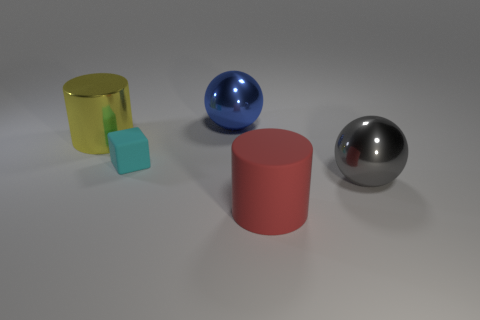What is the color of the object that is both on the left side of the big gray metal ball and to the right of the big blue sphere?
Offer a very short reply. Red. What number of cyan things are the same size as the red rubber object?
Provide a short and direct response. 0. How big is the thing that is left of the blue metallic sphere and in front of the big yellow shiny cylinder?
Provide a short and direct response. Small. How many large blue things are in front of the big shiny ball on the left side of the ball that is to the right of the blue shiny object?
Provide a succinct answer. 0. Are there any large matte things that have the same color as the large metallic cylinder?
Offer a terse response. No. There is a matte object that is the same size as the yellow metallic cylinder; what is its color?
Give a very brief answer. Red. There is a yellow metallic thing left of the large ball that is on the right side of the blue ball right of the yellow object; what is its shape?
Keep it short and to the point. Cylinder. There is a big red matte object right of the large yellow cylinder; how many red objects are to the left of it?
Your answer should be very brief. 0. There is a big object that is right of the large rubber cylinder; is it the same shape as the red object to the right of the large yellow metal cylinder?
Keep it short and to the point. No. There is a gray metallic object; how many blue balls are right of it?
Offer a very short reply. 0. 